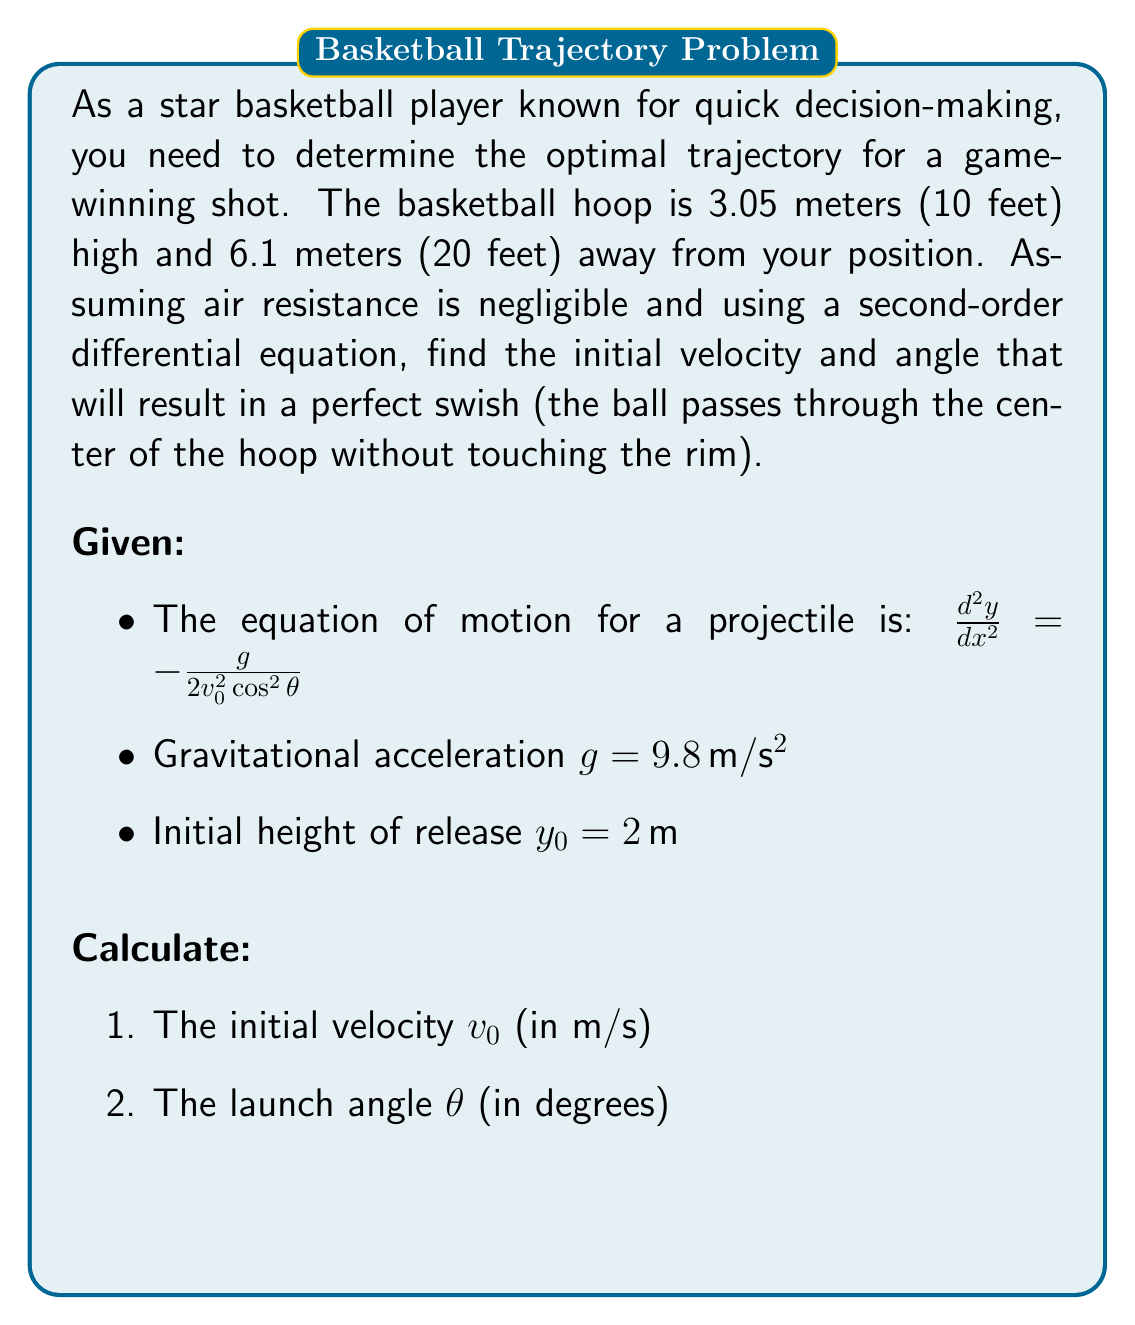What is the answer to this math problem? Let's solve this problem step by step:

1) The second-order differential equation for the trajectory is:

   $$\frac{d^2y}{dx^2} = -\frac{g}{2v_0^2\cos^2\theta}$$

2) Integrating twice, we get the equation of the trajectory:

   $$y = -\frac{g}{2v_0^2\cos^2\theta}x^2 + (\tan\theta)x + y_0$$

3) We know two points on this trajectory:
   - Initial point: $(0, 2)$
   - Hoop point: $(6.1, 3.05)$

4) Substituting these points into the equation:

   For $(0, 2)$: $2 = y_0$ (already given)
   
   For $(6.1, 3.05)$: $3.05 = -\frac{g}{2v_0^2\cos^2\theta}(6.1)^2 + (\tan\theta)(6.1) + 2$

5) We can also use the fact that the derivative $\frac{dy}{dx}$ at $x = 6.1$ should be zero for a perfect swish:

   $$\frac{dy}{dx} = -\frac{g}{v_0^2\cos^2\theta}x + \tan\theta$$
   
   At $x = 6.1$: $0 = -\frac{g}{v_0^2\cos^2\theta}(6.1) + \tan\theta$

6) Now we have two equations with two unknowns ($v_0$ and $\theta$):

   $3.05 = -\frac{9.8}{2v_0^2\cos^2\theta}(6.1)^2 + (\tan\theta)(6.1) + 2$
   
   $0 = -\frac{9.8}{v_0^2\cos^2\theta}(6.1) + \tan\theta$

7) Solving these equations numerically (as they are too complex for analytical solution):

   $v_0 \approx 7.66 \, m/s$
   $\theta \approx 51.28°$

Therefore, the optimal initial velocity is approximately 7.66 m/s, and the optimal launch angle is approximately 51.28 degrees.
Answer: $v_0 \approx 7.66 \, m/s$, $\theta \approx 51.28°$ 